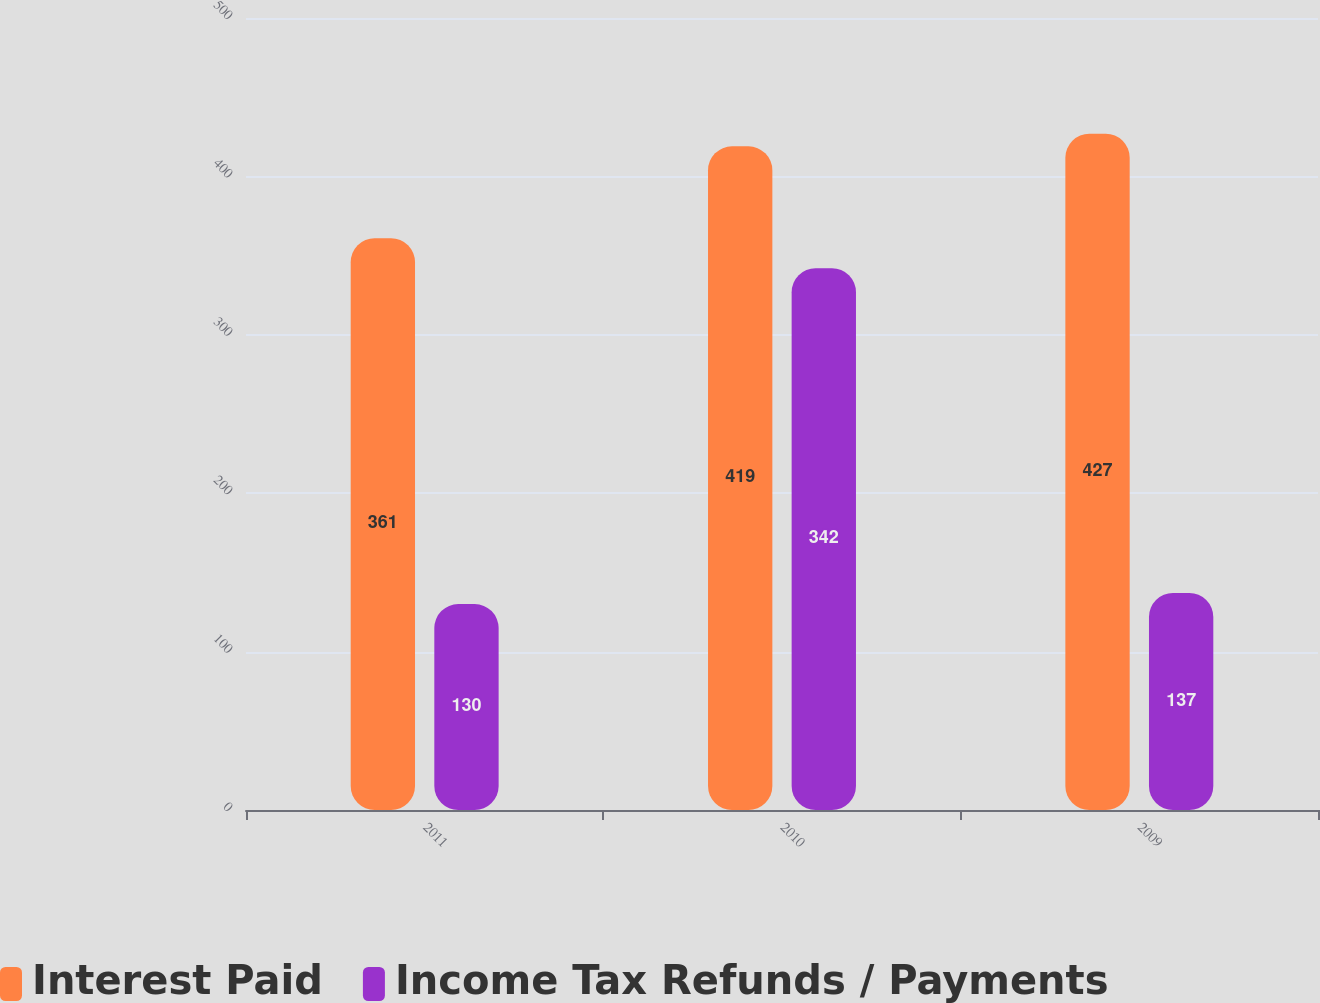<chart> <loc_0><loc_0><loc_500><loc_500><stacked_bar_chart><ecel><fcel>2011<fcel>2010<fcel>2009<nl><fcel>Interest Paid<fcel>361<fcel>419<fcel>427<nl><fcel>Income Tax Refunds / Payments<fcel>130<fcel>342<fcel>137<nl></chart> 